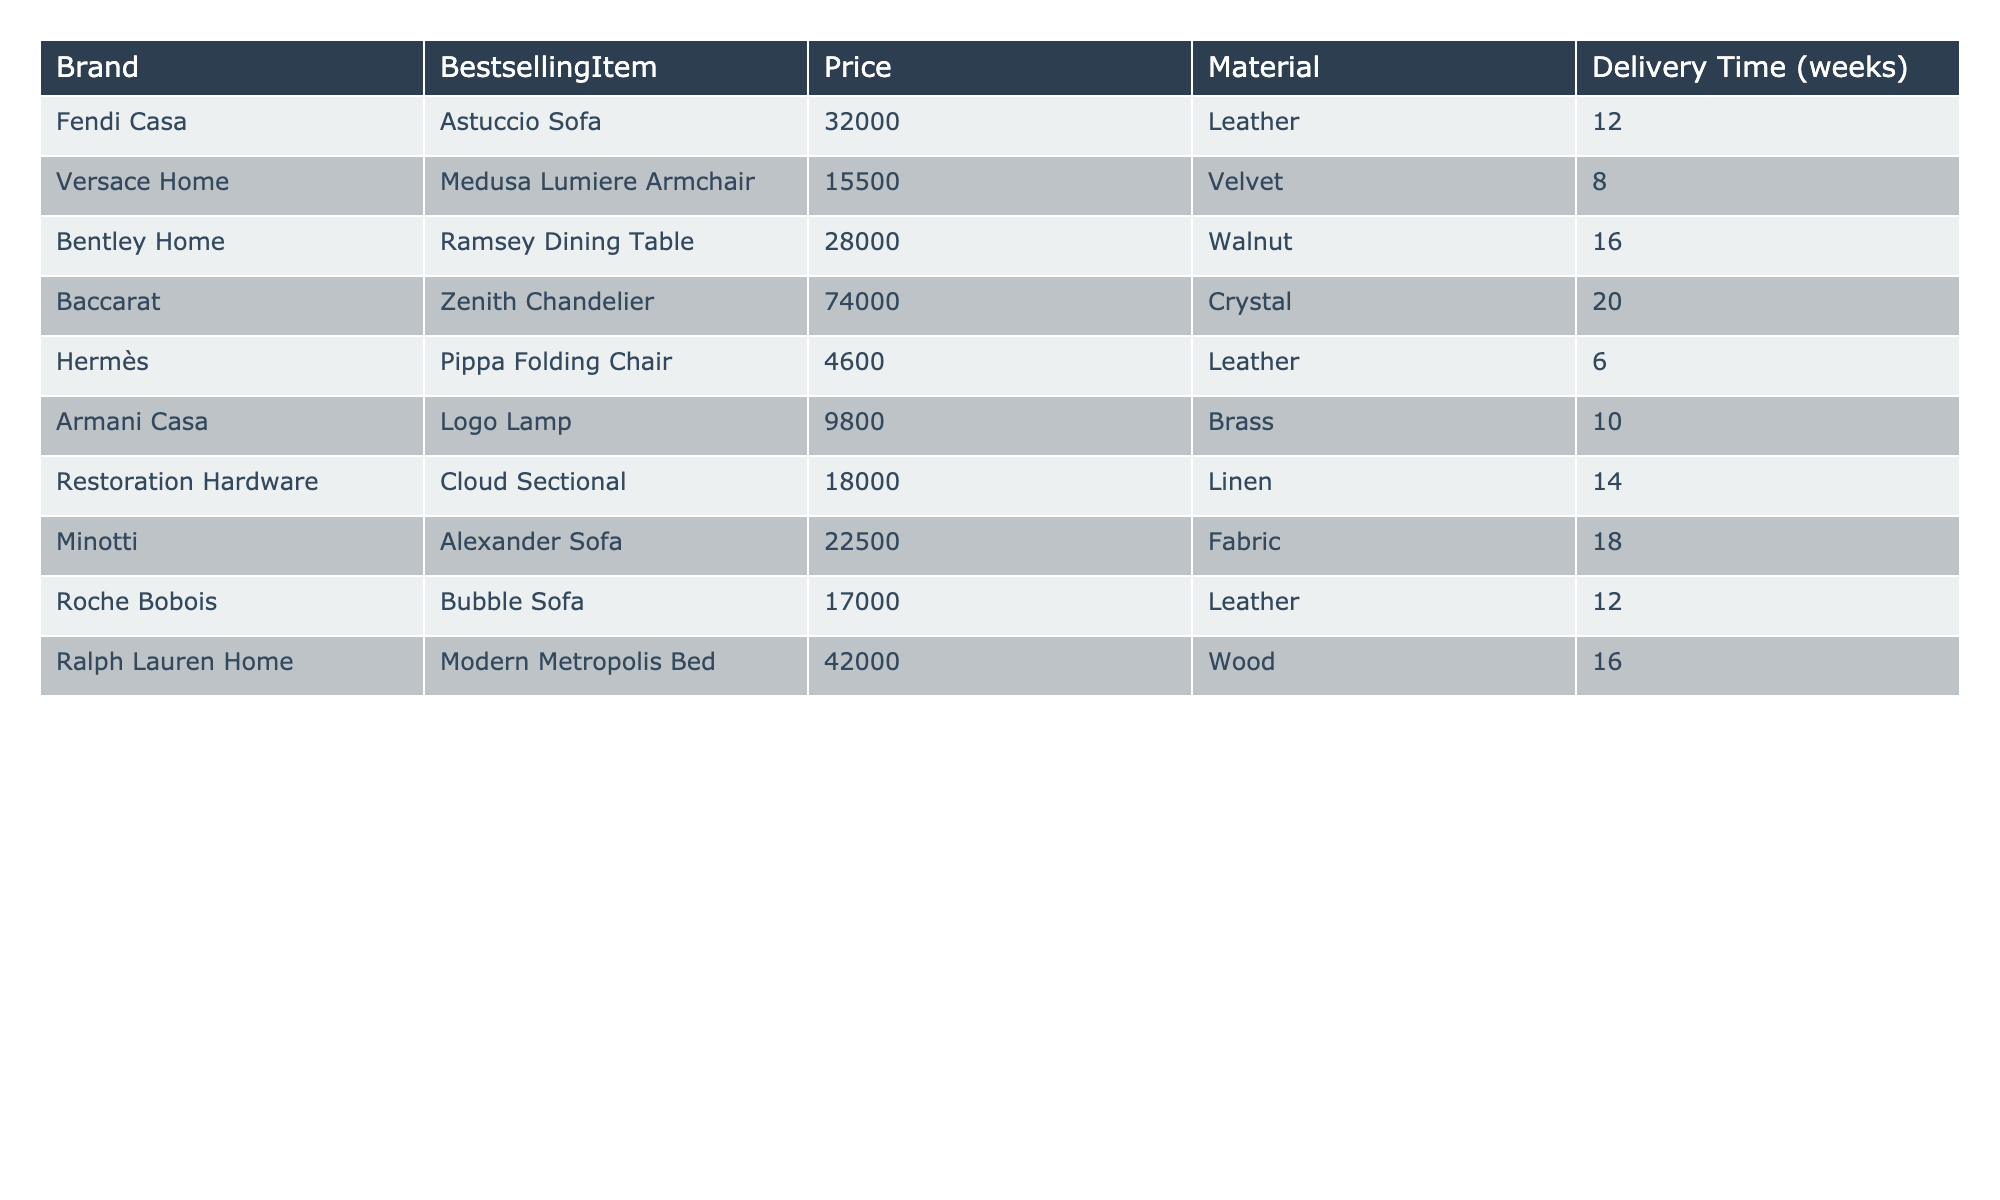What is the price of the Astuccio Sofa? The price of the Astuccio Sofa, which is the bestselling item from Fendi Casa, is listed in the table as 32000.
Answer: 32000 Which material is used for the Zenith Chandelier? The table shows that the material for the Zenith Chandelier from Baccarat is crystal.
Answer: Crystal Is the Pippa Folding Chair the most affordable item in this table? By comparing prices, Pippa Folding Chair is priced at 4600, which is lower than all other items listed, confirming it is the most affordable.
Answer: Yes How long does it take to deliver the Ramsey Dining Table? The table indicates that the delivery time for the Ramsey Dining Table is 16 weeks.
Answer: 16 weeks Which brand has the most expensive item listed? The Zenith Chandelier from Baccarat is the most expensive item at 74000. The prices of all items are checked to find the maximum.
Answer: Baccarat What is the average price of the items made of leather? The leather items listed are the Astuccio Sofa (32000), Pippa Folding Chair (4600), and Bubble Sofa (17000). Adding their prices gives 32000 + 4600 + 17000 = 57600. Dividing by 3 gives an average of 19200.
Answer: 19200 Does any item have a delivery time shorter than 10 weeks? After examining the delivery times, the Pippa Folding Chair has a delivery time of 6 weeks, which is indeed shorter than 10 weeks.
Answer: Yes What is the total delivery time for all items combined? The delivery times are 12, 8, 16, 20, 6, 10, 14, 18, and 16 weeks. Summing these gives a total delivery time of 12 + 8 + 16 + 20 + 6 + 10 + 14 + 18 + 16 = 120 weeks.
Answer: 120 weeks Which brand offers the least expensive upholstered item? The least expensive upholstered item according to the table is the Pippa Folding Chair from Hermès, priced at 4600.
Answer: Hermès Which items have a price greater than 20000? Referring to the table, the items priced over 20000 are Astuccio Sofa (32000), Ramsey Dining Table (28000), and Modern Metropolis Bed (42000).
Answer: Astuccio Sofa, Ramsey Dining Table, Modern Metropolis Bed 